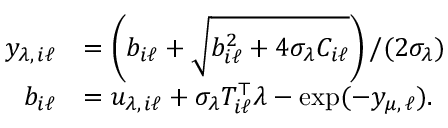Convert formula to latex. <formula><loc_0><loc_0><loc_500><loc_500>\begin{array} { r l } { y _ { \lambda , \, i \ell } } & { = \left ( b _ { i \ell } + \sqrt { b _ { i \ell } ^ { 2 } + 4 \sigma _ { \lambda } C _ { i \ell } } \right ) / ( 2 \sigma _ { \lambda } ) } \\ { b _ { i \ell } } & { = u _ { \lambda , \, i \ell } + \sigma _ { \lambda } T _ { i \ell } ^ { \top } \lambda - \exp ( - y _ { \mu , \, \ell } ) . } \end{array}</formula> 